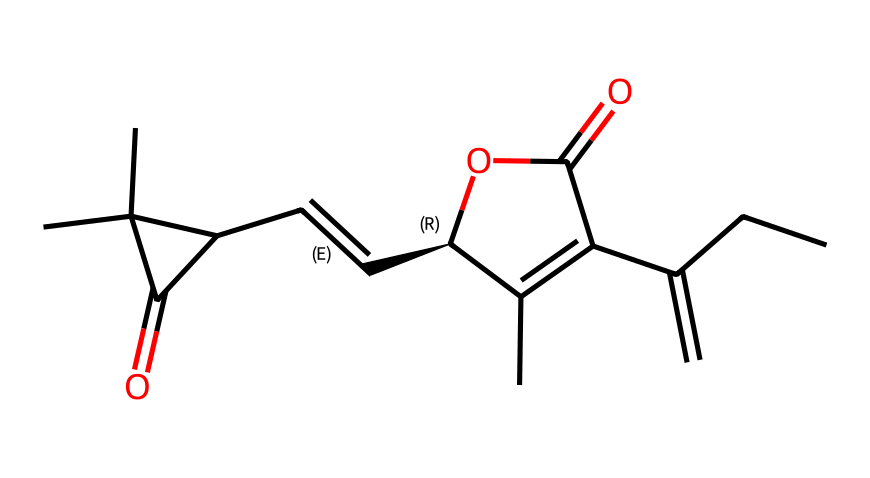How many carbon atoms are in this molecule? By analyzing the SMILES notation, the "C" symbols represent carbon atoms. Counting all the "C" symbols gives a total of 15 carbon atoms in this molecule.
Answer: 15 What functional groups are present in this chemical? The molecule has a carboxylic acid functional group (indicated by the "C(=O)O") and a double bond (indicated by "/C=C/"). These identifiers show the presence of specific functional groups.
Answer: carboxylic acid, alkene What is the degree of unsaturation in this compound? The degree of unsaturation can be calculated based on the formula: U = C + 1 - (H/2) + (N/2) - (X/2). Here, C = 15, H = 22 (deducting the implicit hydrogens), resulting in U = 15 + 1 - (22/2) = 15 + 1 - 11 = 5.
Answer: 5 How many double bonds are in this molecule? By examining the SMILES, the notation "/C=C/" shows there is one double bond indicated in the structure.
Answer: 1 What type of organic compound is represented by this chemical? The presence of a carboxylic acid group and the overall structure suggests that it may belong to a class of organic compounds known as unsaturated fatty acids or derivatives.
Answer: unsaturated fatty acid What is the stereochemistry of this compound? The SMILES notation includes "@", which indicates chirality centers; specifically, the "C@@H" indicates a specific configuration at that carbon atom, showing that it has defined stereochemistry.
Answer: chiral 